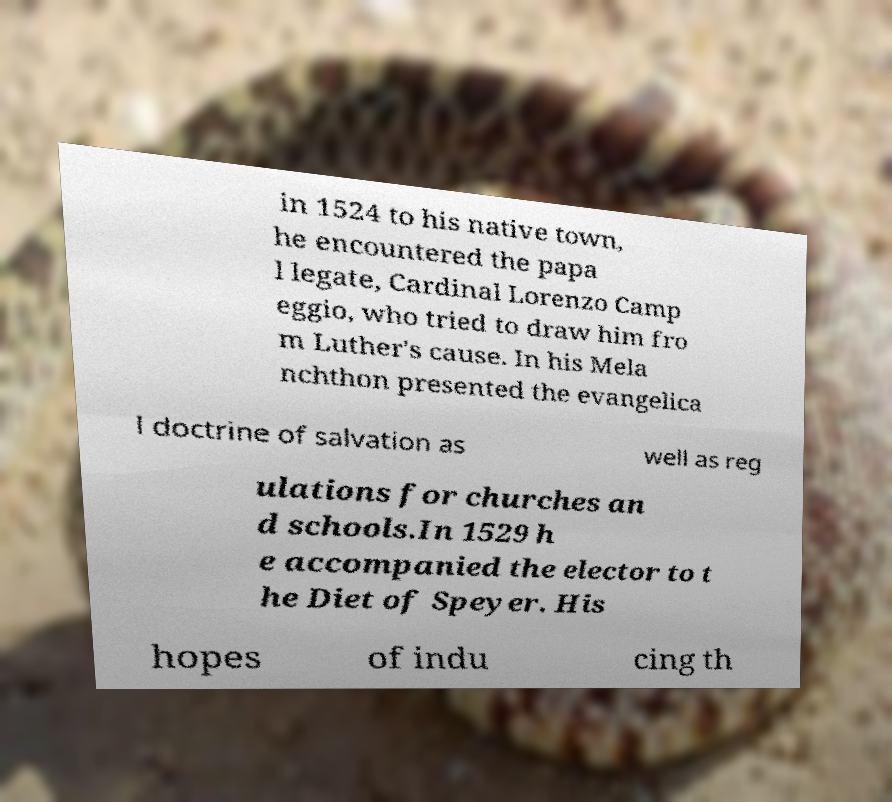Can you read and provide the text displayed in the image?This photo seems to have some interesting text. Can you extract and type it out for me? in 1524 to his native town, he encountered the papa l legate, Cardinal Lorenzo Camp eggio, who tried to draw him fro m Luther's cause. In his Mela nchthon presented the evangelica l doctrine of salvation as well as reg ulations for churches an d schools.In 1529 h e accompanied the elector to t he Diet of Speyer. His hopes of indu cing th 